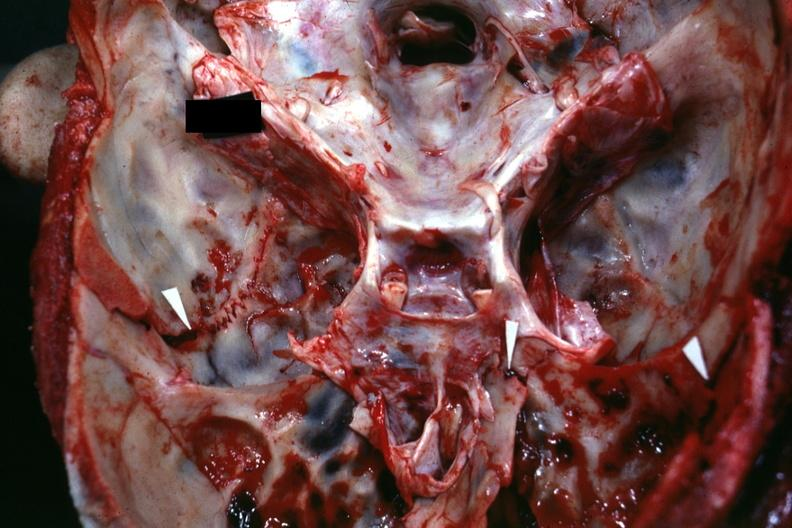what is present?
Answer the question using a single word or phrase. Bone, calvarium 